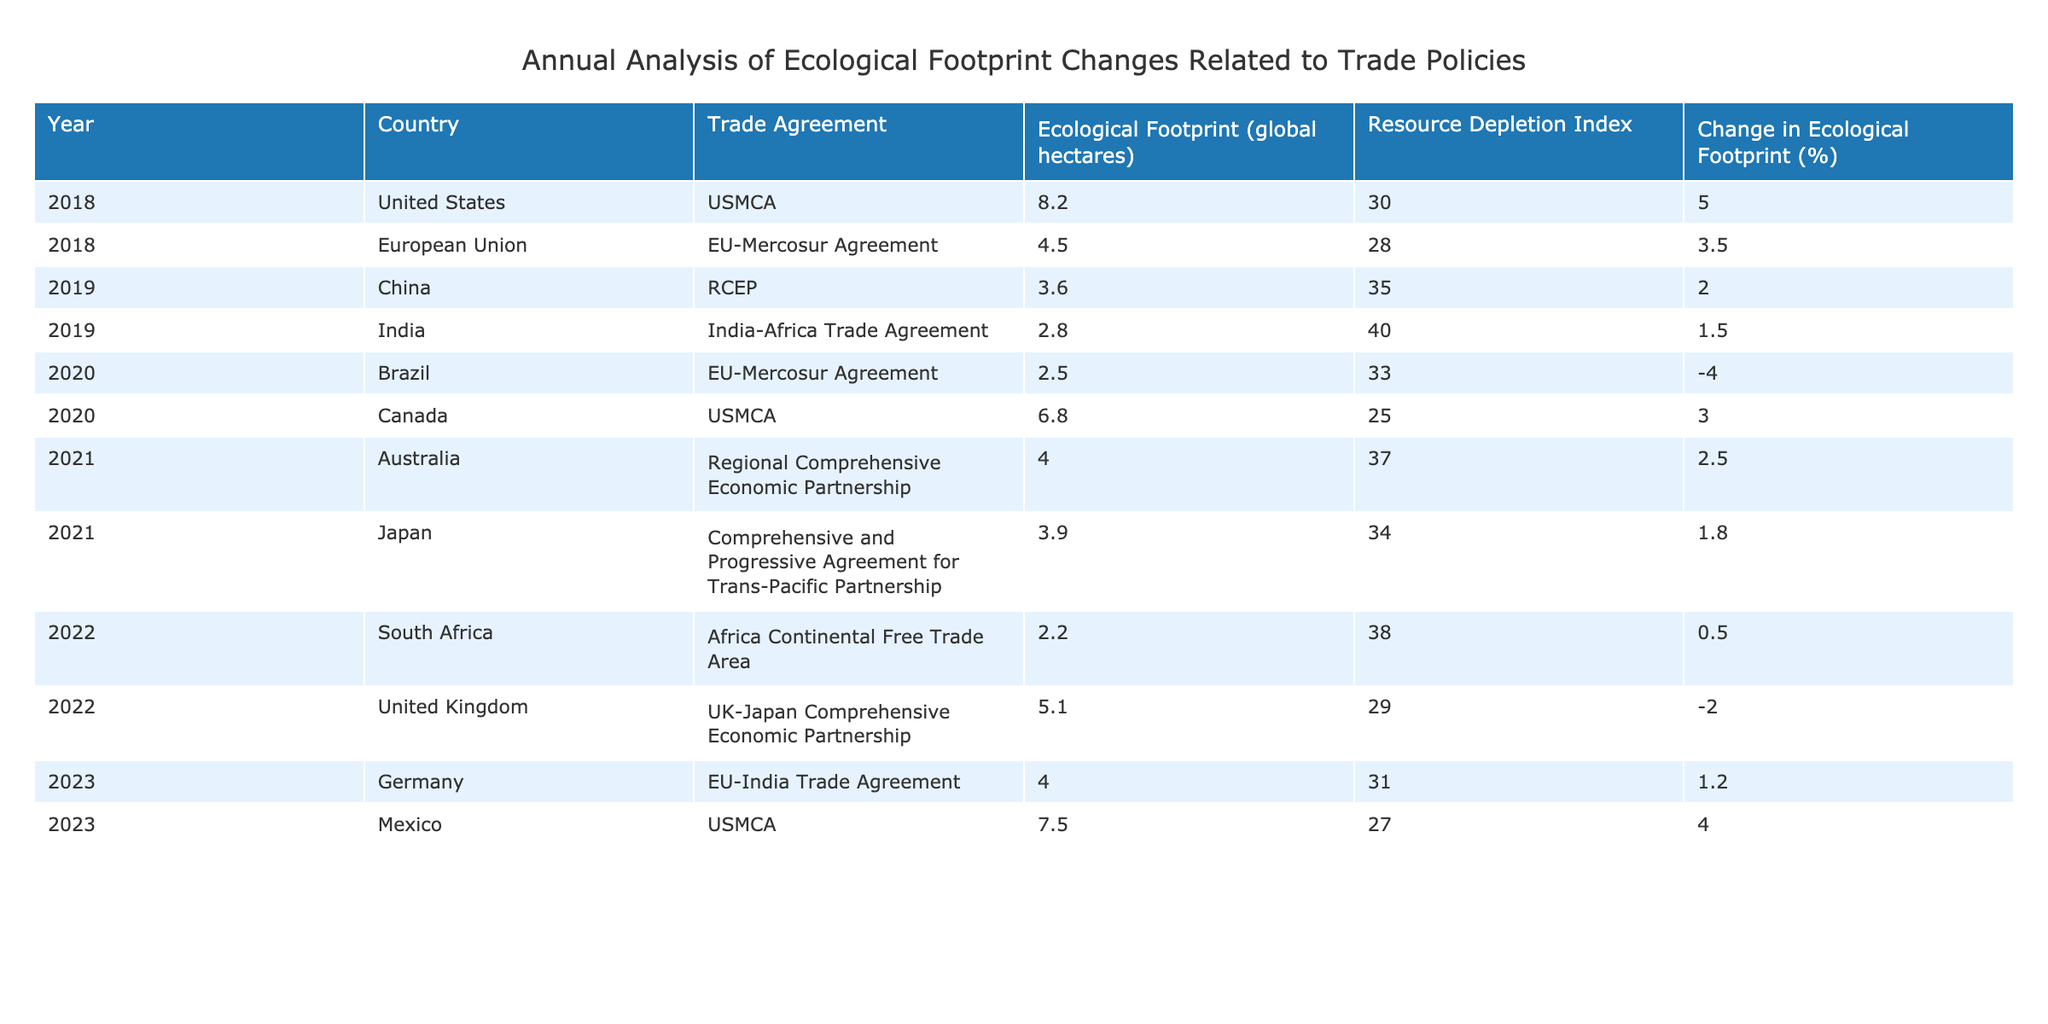What is the ecological footprint of Germany in 2023? In the table, the row corresponding to Germany in 2023 shows an ecological footprint value of 4.0 global hectares.
Answer: 4.0 Which country had the highest ecological footprint in 2018? By examining the values for ecological footprint in 2018, the United States has the highest value of 8.2 global hectares among the listed countries.
Answer: United States What was the average change in ecological footprint from 2018 to 2023 for all listed countries? The changes in ecological footprint percentages from 2018 to 2023 are 5.0, 3.5, 2.0, 1.5, -4.0, 3.0, 2.5, 1.8, 0.5, -2.0, 1.2, 4.0. The total sum is 5.0 + 3.5 + 2.0 + 1.5 - 4.0 + 3.0 + 2.5 + 1.8 + 0.5 - 2.0 + 1.2 + 4.0 = 19.5. There are 12 entries, so the average is 19.5 / 12 = 1.625.
Answer: 1.625 Did the ecological footprint increase for Brazil in 2020 compared to 2019? By examining the footnotes, Brazil's ecological footprint decreased from a value in 2019 (not explicitly stated in the table) to 2.5 in 2020, indicating a reduction in ecological footprint.
Answer: No Which country had the lowest resource depletion index in 2020? The rows for each country in 2020 reveal that Canada had the lowest resource depletion index at 25 when compared to Brazil which had an index of 33.
Answer: Canada How did the ecological footprint of the United Kingdom change from 2022 to 2023? The UK had an ecological footprint of 5.1 in 2022 and 4.0 in 2023. To find the change, we calculate 4.0 - 5.1 = -1.1, indicating a decrease.
Answer: Decreased by 1.1 What percentage of countries experienced a negative change in ecological footprint from 2018 to 2023? Among the countries listed, two (Brazil in 2020 and the UK in 2022) showed a negative change. There are 12 entries total, so the percentage is (2 / 12) * 100 = 16.67%.
Answer: 16.67% Which country consistently had a trade agreement that led to increased ecological footprints from 2018 to 2023? By analyzing the trade agreements related to each country, the USMCA consistently appeared for both the US and Mexico, and their ecological footprints showed increases or stable figures throughout the years.
Answer: United States and Mexico 